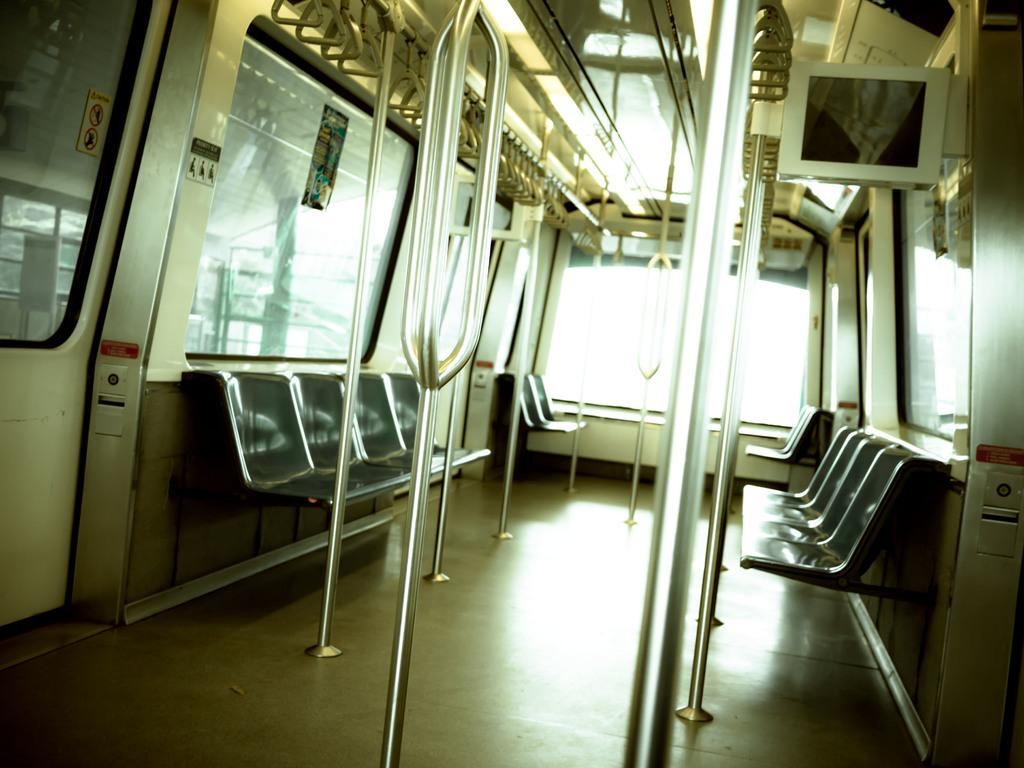What is the setting of the image? The image is inside a vehicle. What type of objects can be seen in the image? There are rods, glass windows, sign boards, posters, lights, seats, and other objects in the image. Can you describe the windows in the image? The windows in the image are made of glass. What might be used for displaying information or advertisements in the image? Sign boards and posters can be used for displaying information or advertisements in the image. What type of lighting is present in the image? There are lights in the image. What type of card is being used to unlock the chain in the image? There is no card or chain present in the image. What fact can be learned about the vehicle from the image? The image does not provide any specific facts about the vehicle; it only shows the interior of the vehicle with various objects and features. 